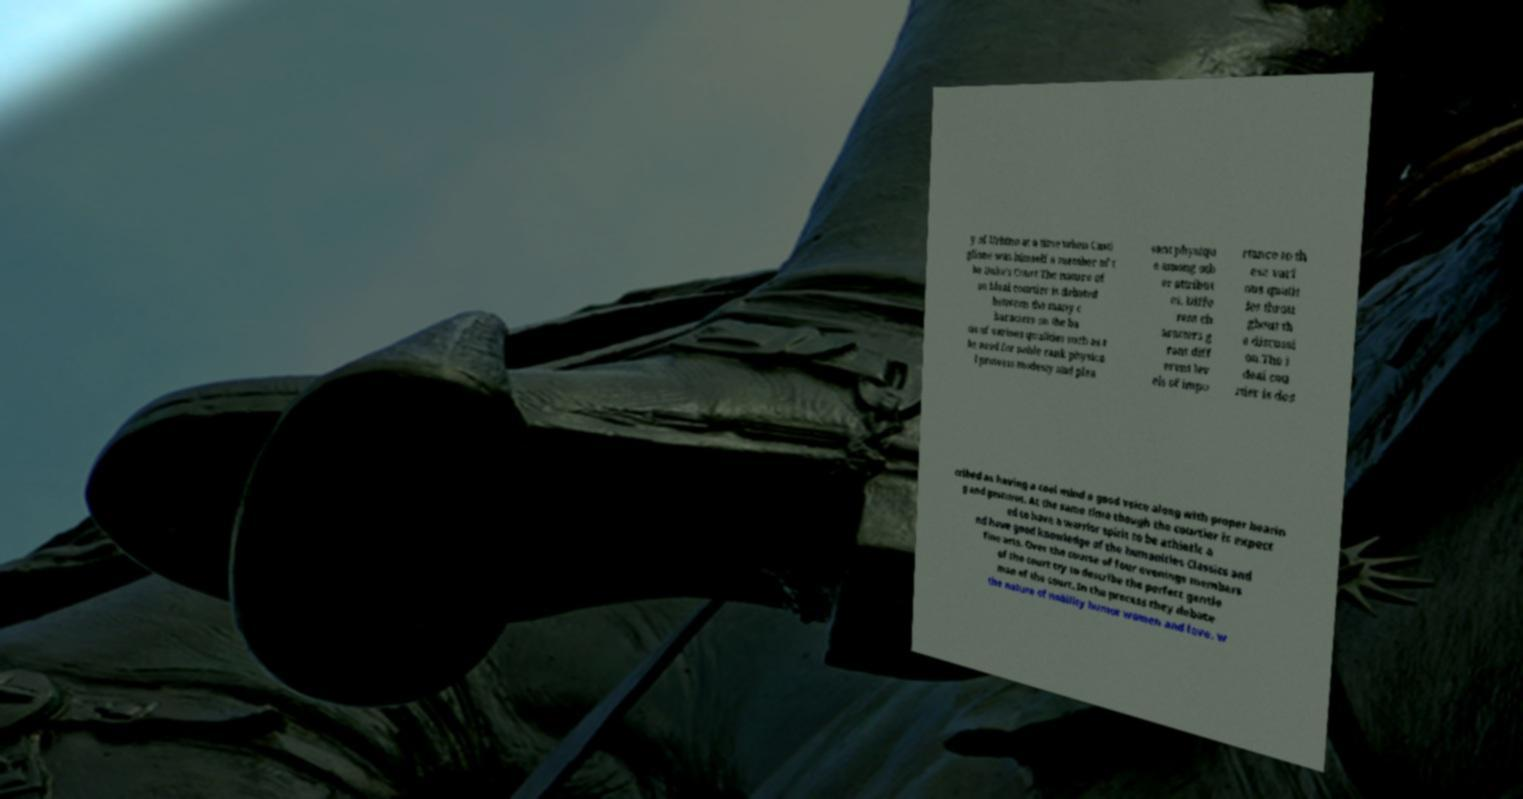Please identify and transcribe the text found in this image. y of Urbino at a time when Casti glione was himself a member of t he Duke's Court The nature of an ideal courtier is debated between the many c haracters on the ba sis of various qualities such as t he need for noble rank physica l prowess modesty and plea sant physiqu e among oth er attribut es. Diffe rent ch aracters g rant diff erent lev els of impo rtance to th ese vari ous qualit ies throu ghout th e discussi on.The i deal cou rtier is des cribed as having a cool mind a good voice along with proper bearin g and gestures. At the same time though the courtier is expect ed to have a warrior spirit to be athletic a nd have good knowledge of the humanities Classics and fine arts. Over the course of four evenings members of the court try to describe the perfect gentle man of the court. In the process they debate the nature of nobility humor women and love. w 